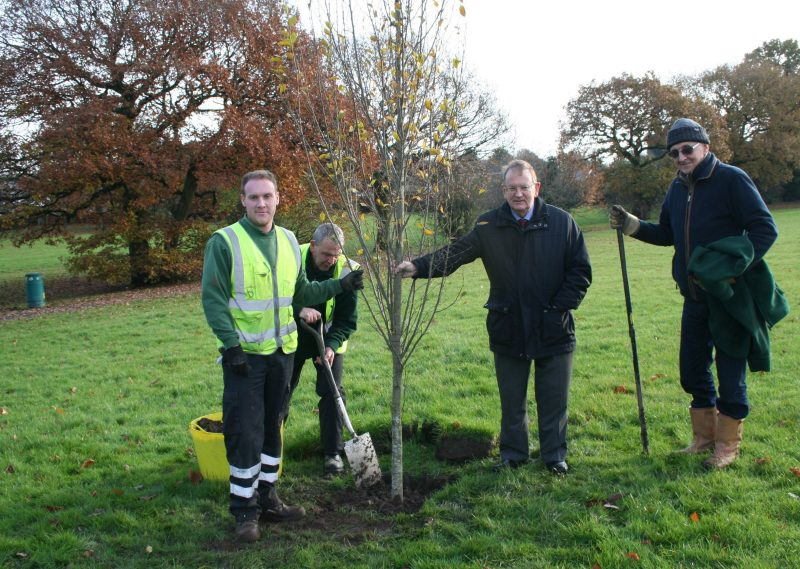How do you think the community benefits from this tree planting activity? Tree planting activities provide numerous benefits to the community. They help improve air quality by absorbing carbon dioxide and releasing oxygen, enhance the aesthetic appeal of public spaces, and provide shade and habitat for wildlife. Additionally, such activities foster community spirit and engagement, as people come together for a common cause. The tree planted today will grow over the years, symbolizing the community's commitment to sustainability and environmental stewardship. What might be the long-term impacts of planting this tree in this location? In the long term, planting this tree will have several positive impacts on the local environment and community. As it matures, the tree will provide significant shade, making the park more inviting and comfortable during hot summer days. It will contribute to reducing the urban heat island effect, as trees can lower local temperatures through shading and evapotranspiration. The tree will also help to prevent soil erosion, support biodiversity by offering a habitat for various birds and insects, and improve the overall ecological health of the area. Furthermore, it will serve as a living testament to the community's dedication to protecting the environment for future generations. Can you imagine a creative story surrounding this tree and the people planting it? Once upon a time, in a small, picturesque village surrounded by ancient trees and vibrant wildflowers, there was a tradition that every year, the villagers would gather to plant a tree in the central park. This tradition went back centuries, each tree symbolizing a story, a memory, or a hope for the future. This year's gathering was particularly special. Among the villagers was an elderly man, Mr. Thomason, who had planted the very first tree when he was just a boy. He shared tales of how every tree they had planted blossomed with the most beautiful flowers, each bearing a unique scent that could only be described as magical.

As the villagers dug the hole for the new tree, an old woman, Mrs. Willow, began to sing an ancient lullaby, believed to bring good luck and growth to the sapling. Children danced around, chasing each other with garlands of flowers, while the adults reminisced about the past and dreamt of the future. Mr. Thomason, with tears glistening in his eyes, placed the young tree into the ground, remembering his own childhood and all the generations that had come and gone.

Legend had it that the first tree Mr. Thomason planted had a secret – it was said to be connected to the heart of the forest, a mystical place where trees could whisper the stories of old. The villagers believed that every tree they planted carried the whispers of their ancestors, and this tree, too, would grow to share its wisdom with future generations. It was a tree planted not just for the environment, but for the spirit and heritage of the village, a living beacon of peace, unity, and continuity in an ever-changing world. 